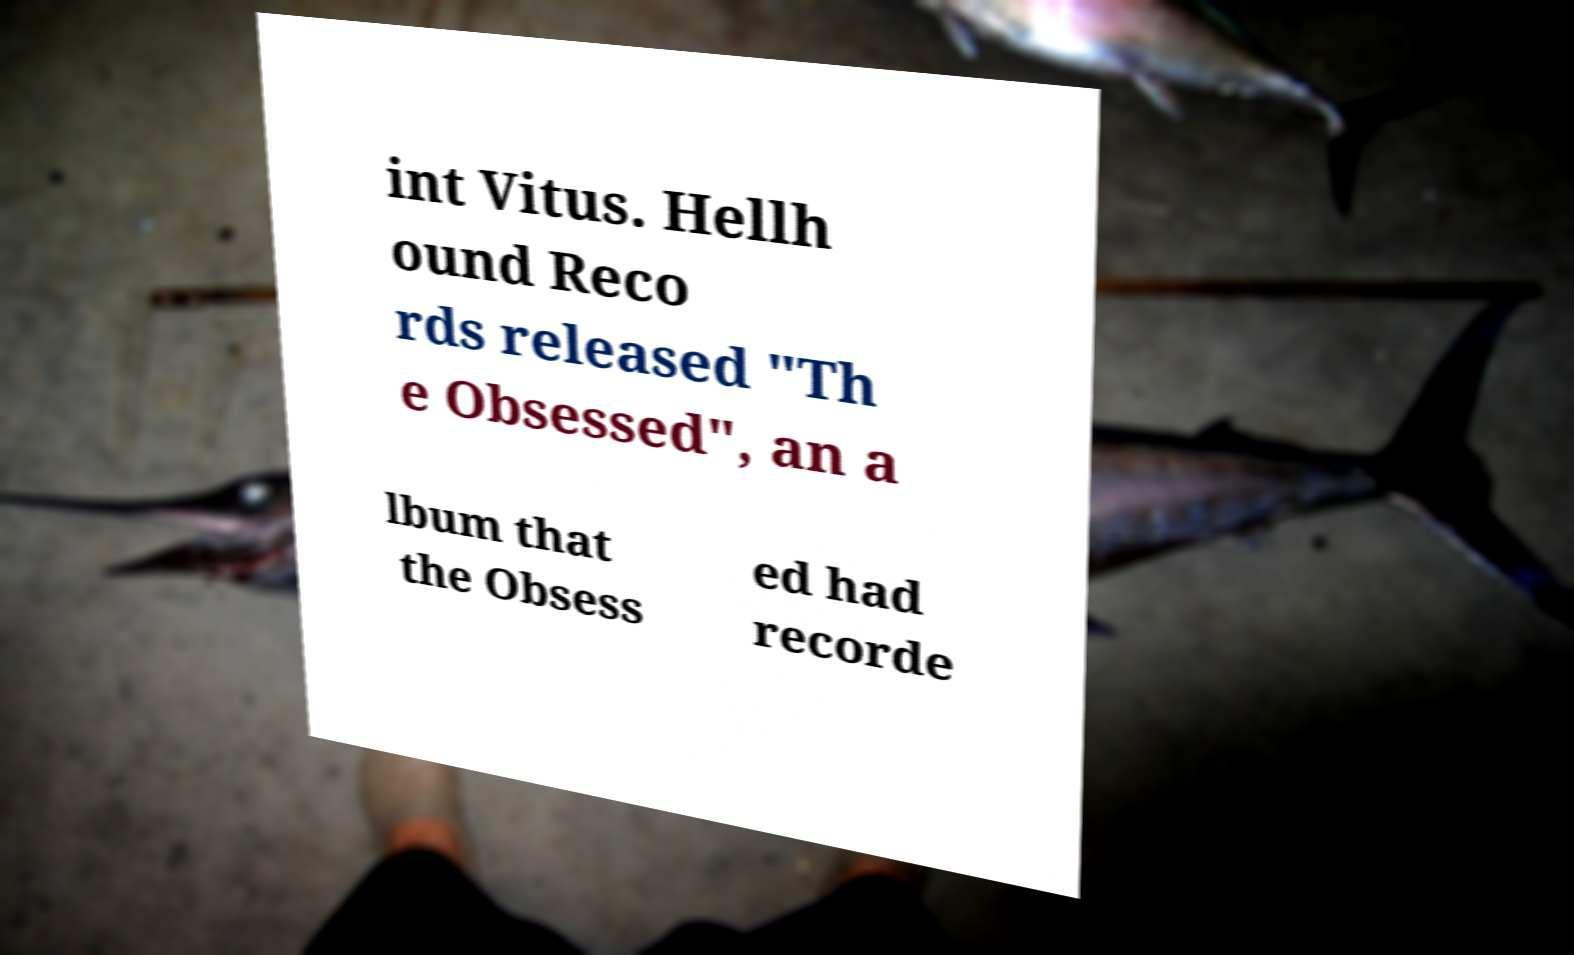Can you read and provide the text displayed in the image?This photo seems to have some interesting text. Can you extract and type it out for me? int Vitus. Hellh ound Reco rds released "Th e Obsessed", an a lbum that the Obsess ed had recorde 